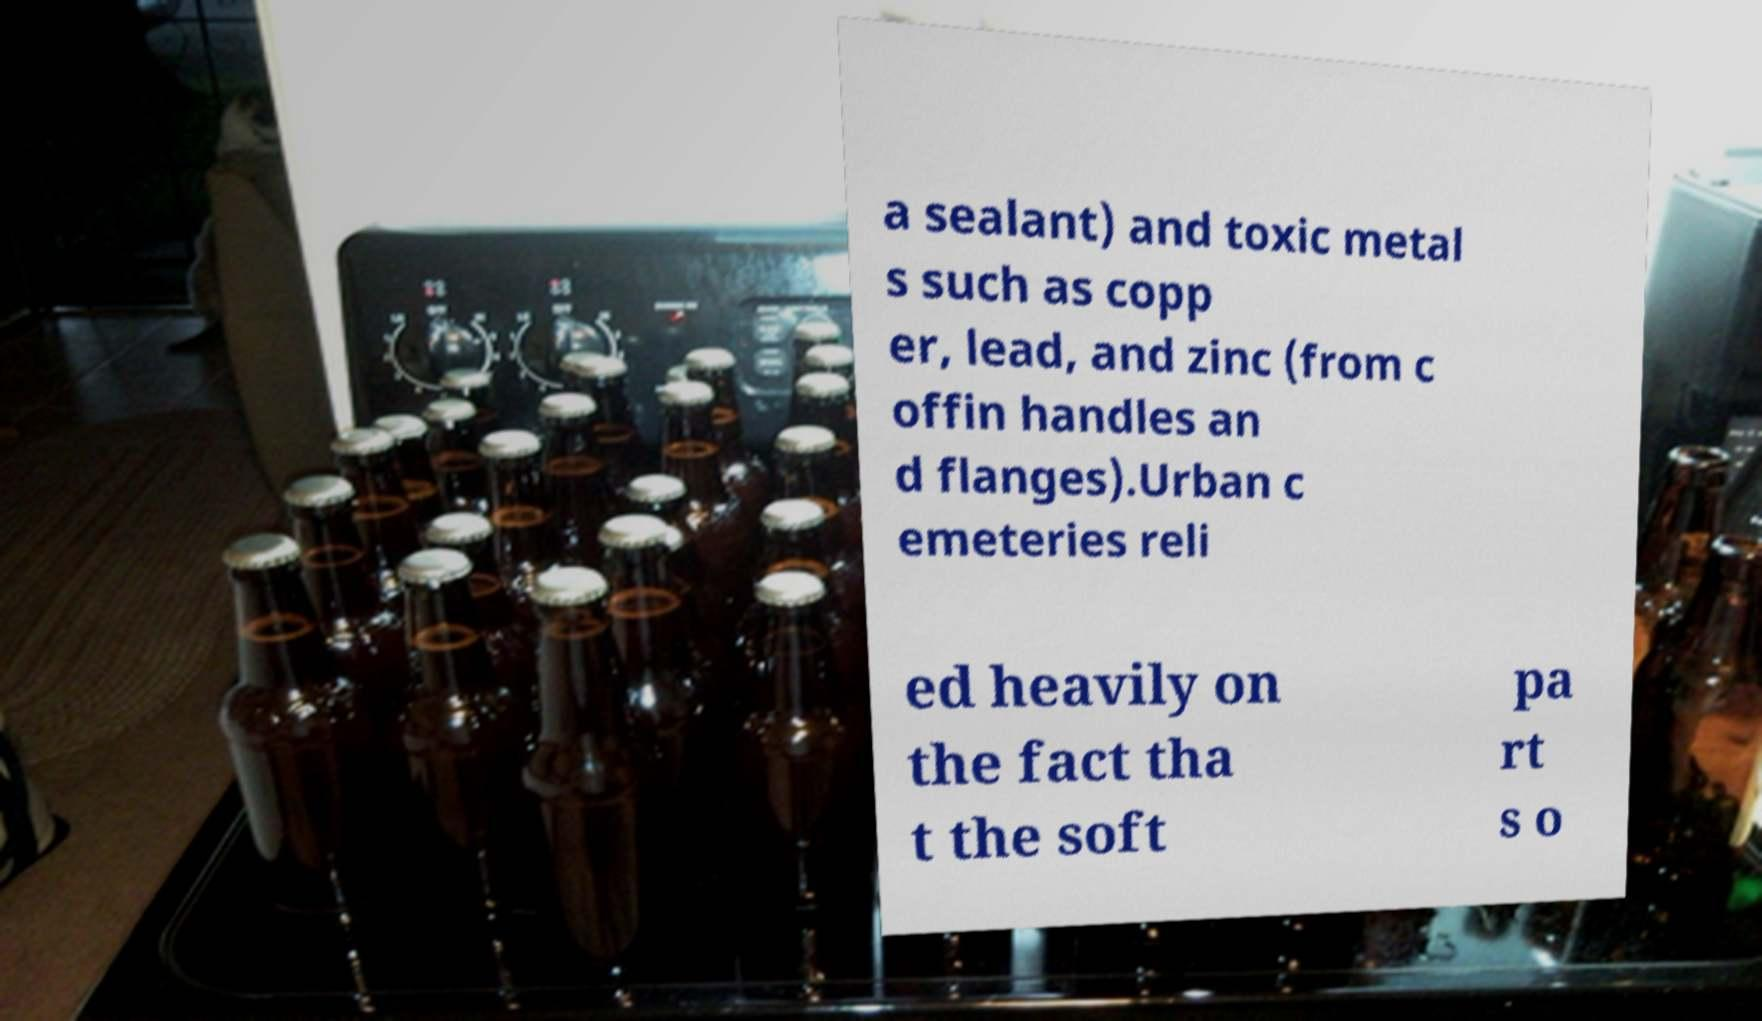There's text embedded in this image that I need extracted. Can you transcribe it verbatim? a sealant) and toxic metal s such as copp er, lead, and zinc (from c offin handles an d flanges).Urban c emeteries reli ed heavily on the fact tha t the soft pa rt s o 